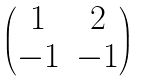Convert formula to latex. <formula><loc_0><loc_0><loc_500><loc_500>\begin{pmatrix} 1 & 2 \\ - 1 & - 1 \end{pmatrix}</formula> 